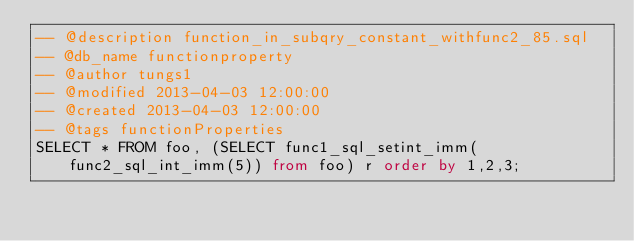<code> <loc_0><loc_0><loc_500><loc_500><_SQL_>-- @description function_in_subqry_constant_withfunc2_85.sql
-- @db_name functionproperty
-- @author tungs1
-- @modified 2013-04-03 12:00:00
-- @created 2013-04-03 12:00:00
-- @tags functionProperties 
SELECT * FROM foo, (SELECT func1_sql_setint_imm(func2_sql_int_imm(5)) from foo) r order by 1,2,3; 
</code> 